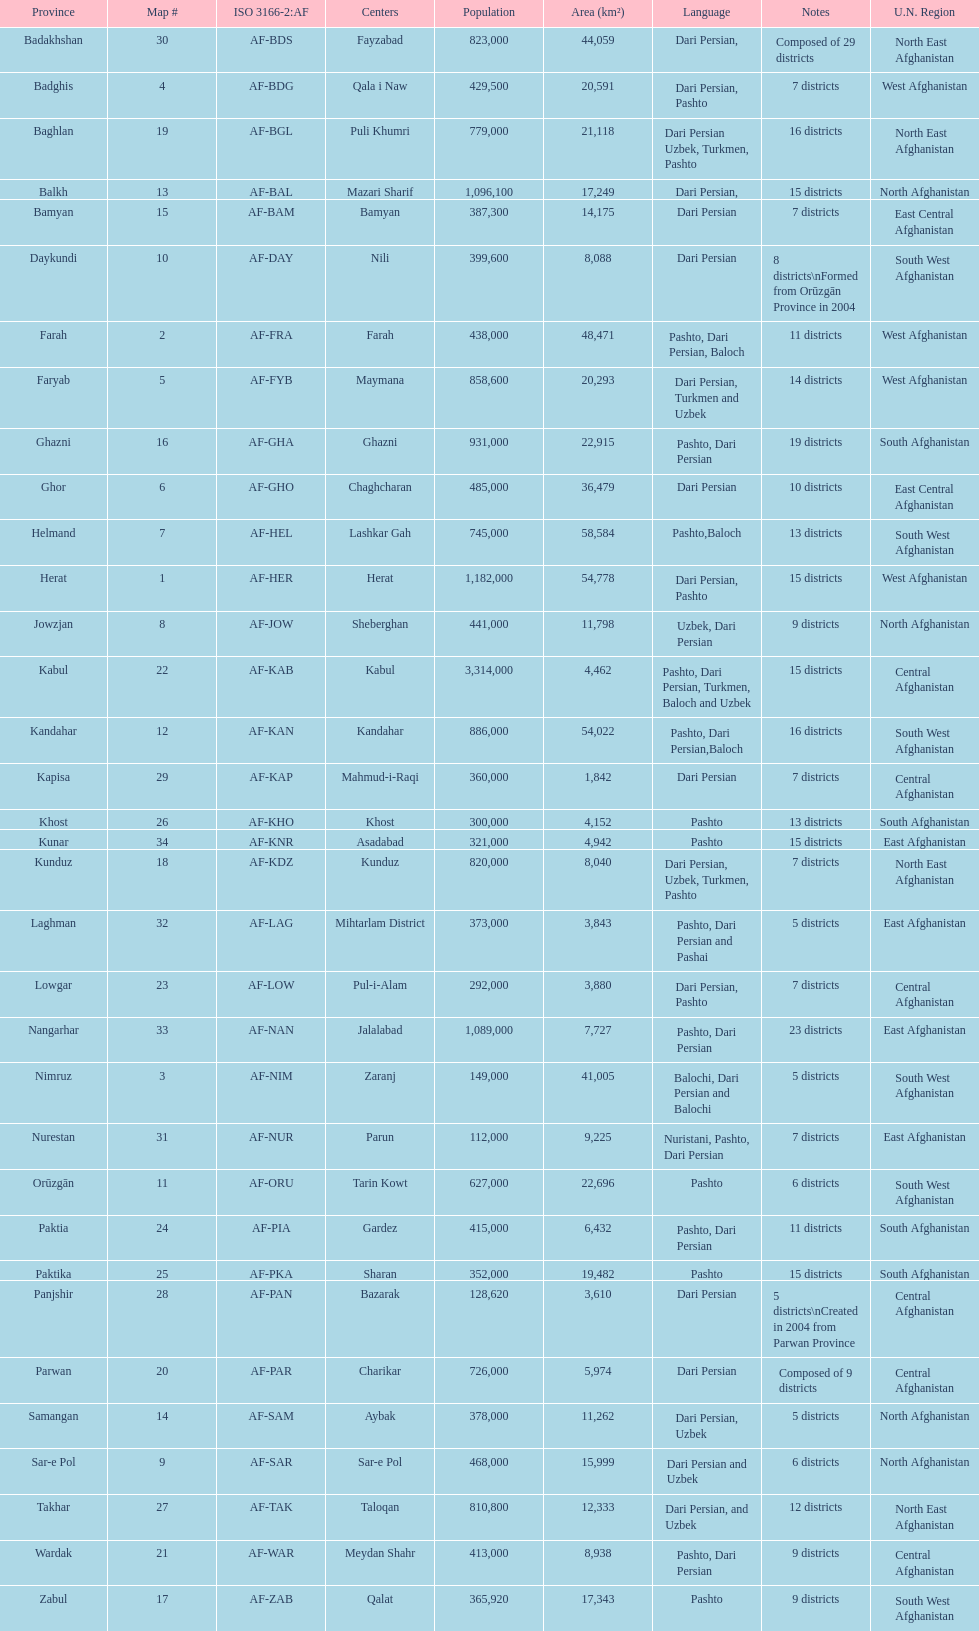In how many provinces is pashto considered one of the languages spoken? 20. 